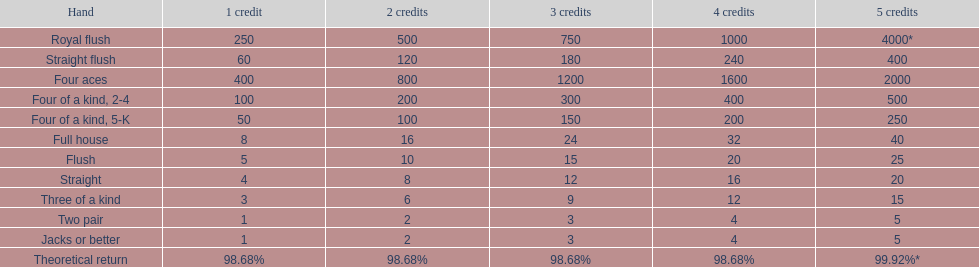What is the difference of payout on 3 credits, between a straight flush and royal flush? 570. 